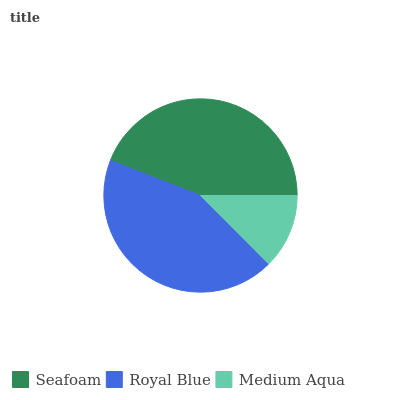Is Medium Aqua the minimum?
Answer yes or no. Yes. Is Seafoam the maximum?
Answer yes or no. Yes. Is Royal Blue the minimum?
Answer yes or no. No. Is Royal Blue the maximum?
Answer yes or no. No. Is Seafoam greater than Royal Blue?
Answer yes or no. Yes. Is Royal Blue less than Seafoam?
Answer yes or no. Yes. Is Royal Blue greater than Seafoam?
Answer yes or no. No. Is Seafoam less than Royal Blue?
Answer yes or no. No. Is Royal Blue the high median?
Answer yes or no. Yes. Is Royal Blue the low median?
Answer yes or no. Yes. Is Medium Aqua the high median?
Answer yes or no. No. Is Medium Aqua the low median?
Answer yes or no. No. 